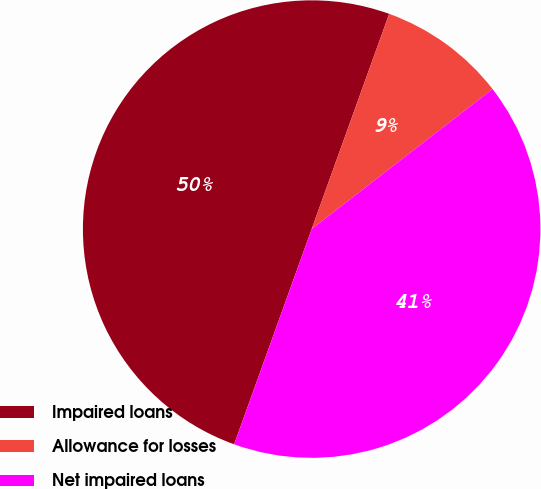<chart> <loc_0><loc_0><loc_500><loc_500><pie_chart><fcel>Impaired loans<fcel>Allowance for losses<fcel>Net impaired loans<nl><fcel>50.0%<fcel>9.01%<fcel>40.99%<nl></chart> 